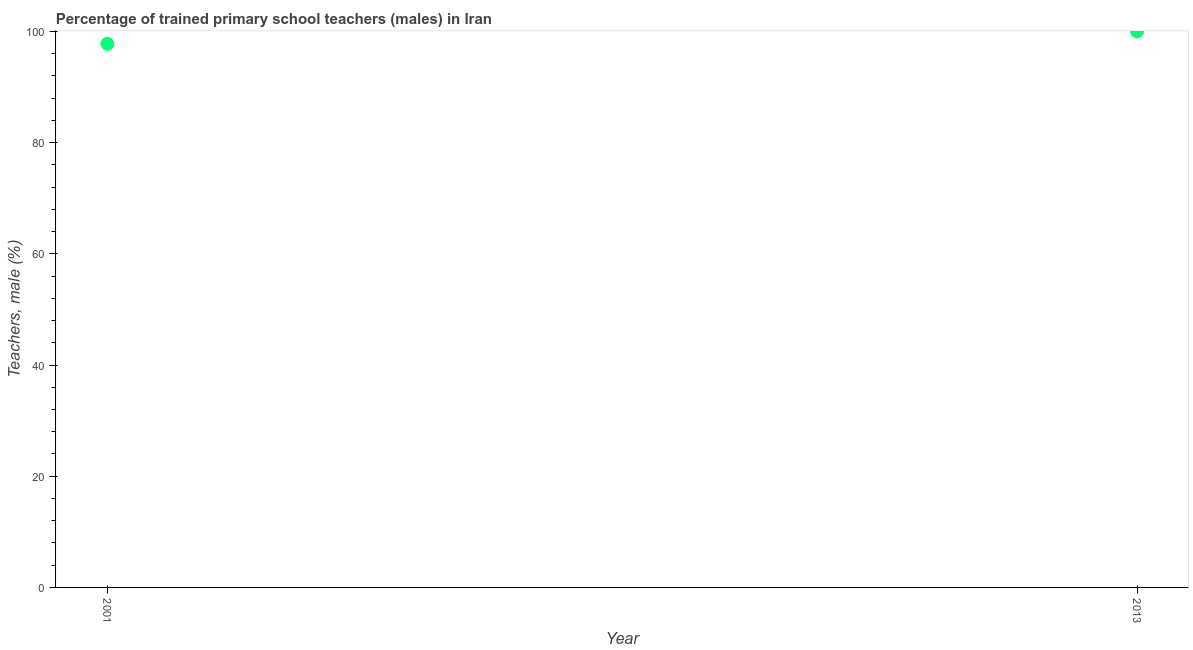What is the percentage of trained male teachers in 2013?
Keep it short and to the point. 100. Across all years, what is the maximum percentage of trained male teachers?
Your response must be concise. 100. Across all years, what is the minimum percentage of trained male teachers?
Offer a terse response. 97.78. In which year was the percentage of trained male teachers maximum?
Give a very brief answer. 2013. In which year was the percentage of trained male teachers minimum?
Provide a short and direct response. 2001. What is the sum of the percentage of trained male teachers?
Provide a succinct answer. 197.78. What is the difference between the percentage of trained male teachers in 2001 and 2013?
Your answer should be compact. -2.22. What is the average percentage of trained male teachers per year?
Your response must be concise. 98.89. What is the median percentage of trained male teachers?
Provide a short and direct response. 98.89. In how many years, is the percentage of trained male teachers greater than 36 %?
Make the answer very short. 2. What is the ratio of the percentage of trained male teachers in 2001 to that in 2013?
Offer a terse response. 0.98. Is the percentage of trained male teachers in 2001 less than that in 2013?
Give a very brief answer. Yes. Does the percentage of trained male teachers monotonically increase over the years?
Give a very brief answer. Yes. How many dotlines are there?
Provide a short and direct response. 1. What is the difference between two consecutive major ticks on the Y-axis?
Give a very brief answer. 20. Are the values on the major ticks of Y-axis written in scientific E-notation?
Make the answer very short. No. Does the graph contain any zero values?
Ensure brevity in your answer.  No. What is the title of the graph?
Give a very brief answer. Percentage of trained primary school teachers (males) in Iran. What is the label or title of the Y-axis?
Your response must be concise. Teachers, male (%). What is the Teachers, male (%) in 2001?
Offer a very short reply. 97.78. What is the difference between the Teachers, male (%) in 2001 and 2013?
Ensure brevity in your answer.  -2.22. What is the ratio of the Teachers, male (%) in 2001 to that in 2013?
Your response must be concise. 0.98. 